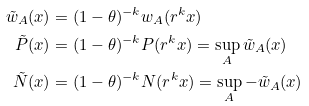<formula> <loc_0><loc_0><loc_500><loc_500>\tilde { w } _ { A } ( x ) & = ( 1 - \theta ) ^ { - k } w _ { A } ( r ^ { k } x ) \\ \tilde { P } ( x ) & = ( 1 - \theta ) ^ { - k } P ( r ^ { k } x ) = \sup _ { A } \tilde { w } _ { A } ( x ) \\ \tilde { N } ( x ) & = ( 1 - \theta ) ^ { - k } N ( r ^ { k } x ) = \sup _ { A } - \tilde { w } _ { A } ( x )</formula> 